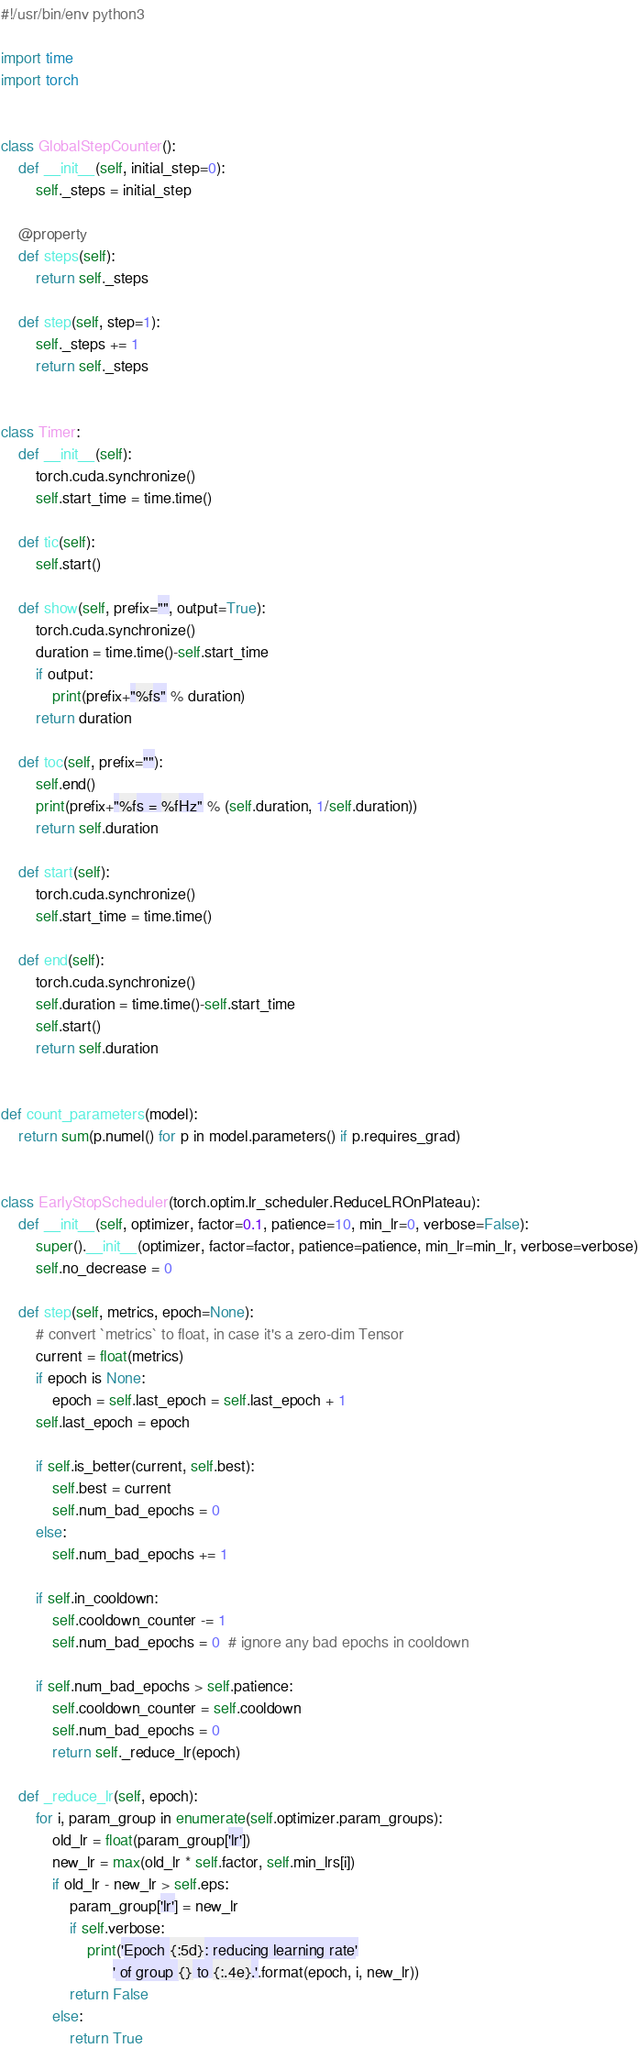Convert code to text. <code><loc_0><loc_0><loc_500><loc_500><_Python_>#!/usr/bin/env python3

import time
import torch


class GlobalStepCounter():
    def __init__(self, initial_step=0):
        self._steps = initial_step

    @property
    def steps(self):
        return self._steps

    def step(self, step=1):
        self._steps += 1
        return self._steps


class Timer:
    def __init__(self):
        torch.cuda.synchronize()
        self.start_time = time.time()

    def tic(self):
        self.start()

    def show(self, prefix="", output=True):
        torch.cuda.synchronize()
        duration = time.time()-self.start_time
        if output:
            print(prefix+"%fs" % duration)
        return duration

    def toc(self, prefix=""):
        self.end()
        print(prefix+"%fs = %fHz" % (self.duration, 1/self.duration))
        return self.duration

    def start(self):
        torch.cuda.synchronize()
        self.start_time = time.time()

    def end(self):
        torch.cuda.synchronize()
        self.duration = time.time()-self.start_time
        self.start()
        return self.duration


def count_parameters(model):
    return sum(p.numel() for p in model.parameters() if p.requires_grad)


class EarlyStopScheduler(torch.optim.lr_scheduler.ReduceLROnPlateau):
    def __init__(self, optimizer, factor=0.1, patience=10, min_lr=0, verbose=False):
        super().__init__(optimizer, factor=factor, patience=patience, min_lr=min_lr, verbose=verbose)
        self.no_decrease = 0

    def step(self, metrics, epoch=None):
        # convert `metrics` to float, in case it's a zero-dim Tensor
        current = float(metrics)
        if epoch is None:
            epoch = self.last_epoch = self.last_epoch + 1
        self.last_epoch = epoch

        if self.is_better(current, self.best):
            self.best = current
            self.num_bad_epochs = 0
        else:
            self.num_bad_epochs += 1

        if self.in_cooldown:
            self.cooldown_counter -= 1
            self.num_bad_epochs = 0  # ignore any bad epochs in cooldown

        if self.num_bad_epochs > self.patience:
            self.cooldown_counter = self.cooldown
            self.num_bad_epochs = 0
            return self._reduce_lr(epoch)

    def _reduce_lr(self, epoch):
        for i, param_group in enumerate(self.optimizer.param_groups):
            old_lr = float(param_group['lr'])
            new_lr = max(old_lr * self.factor, self.min_lrs[i])
            if old_lr - new_lr > self.eps:
                param_group['lr'] = new_lr
                if self.verbose:
                    print('Epoch {:5d}: reducing learning rate'
                          ' of group {} to {:.4e}.'.format(epoch, i, new_lr))
                return False
            else:
                return True
</code> 